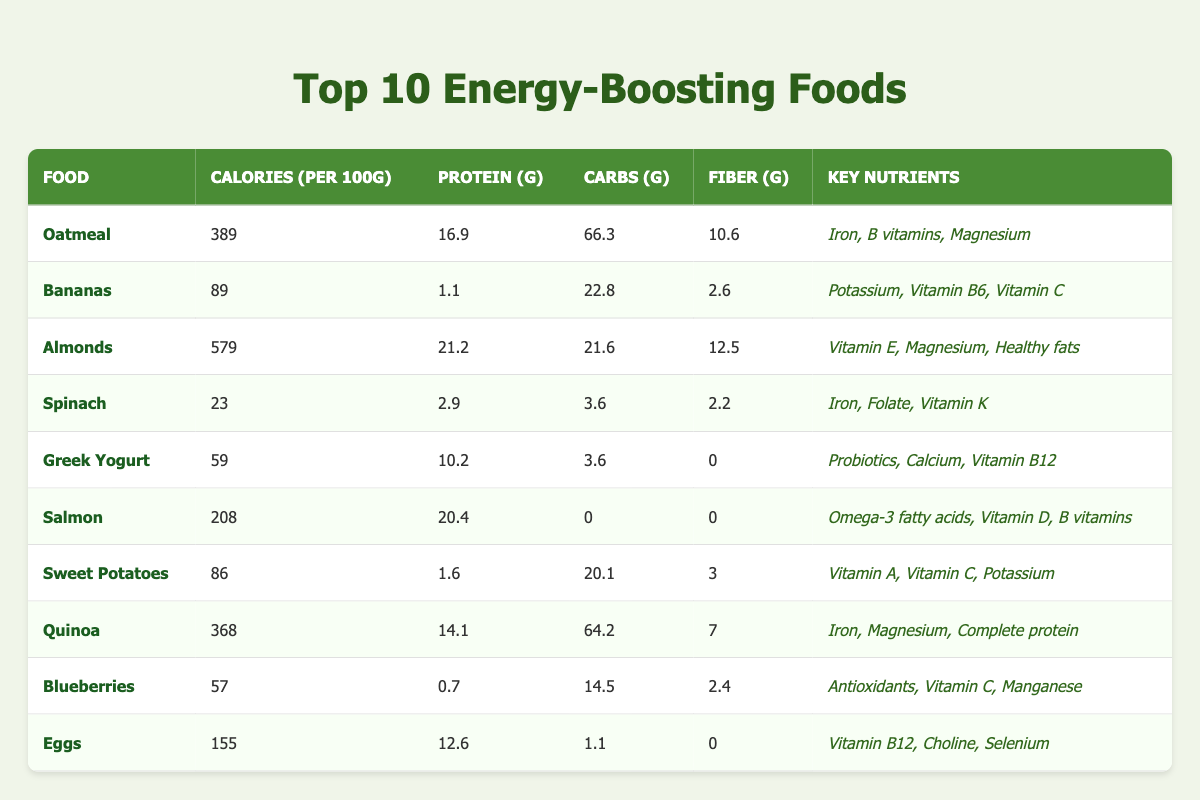What food has the highest protein content? Looking through the table, Almonds have the highest protein content at 21.2 grams per 100g.
Answer: Almonds Which food has the least calories? By scanning the Calories column, Spinach has the least calories with 23 calories per 100g.
Answer: Spinach What is the average carbohydrate content of the top 10 foods? Calculating the average requires summing the carbohydrate content from each food (66.3 + 22.8 + 21.6 + 3.6 + 3.6 + 0 + 20.1 + 64.2 + 14.5 + 1.1) = 204.8. There are 10 foods, so the average is 204.8/10 = 20.48 grams.
Answer: 20.48 grams Does Greek Yogurt contain Vitamin D? Looking at the Key Nutrients column for Greek Yogurt shows it contains Probiotics, Calcium, and Vitamin B12 but no mention of Vitamin D, thus the answer is No.
Answer: No Which food(s) provide Omega-3 fatty acids? Checking the Key Nutrients column, only Salmon mentions Omega-3 fatty acids, making it the sole food in this category.
Answer: Salmon What is the total fiber content of Eggs and Bananas combined? From the table, Bananas have 2.6 grams of fiber and Eggs have 0 grams. Adding them together (2.6 + 0) gives a total fiber content of 2.6 grams.
Answer: 2.6 grams Is Sweet Potatoes high in protein compared to Spinach? Sweet Potatoes have 1.6 grams of protein, while Spinach has 2.9 grams. Spinach has more protein; therefore, the statement is False.
Answer: False Which food has the highest carbohydrate content? Looking through the Carbs column, Oatmeal has the highest carbohydrate content with 66.3 grams per 100g.
Answer: Oatmeal What percentage of calories do Almonds contribute to the total calorie count of all foods combined? First, calculate the total calories for all foods (389 + 89 + 579 + 23 + 59 + 208 + 86 + 368 + 57 + 155) = 2062 calories. Almonds provide 579 calories. The percentage is calculated as (579/2062) * 100 = approximately 28.05%.
Answer: 28.05% 